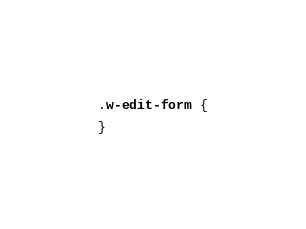<code> <loc_0><loc_0><loc_500><loc_500><_CSS_>.w-edit-form {

}</code> 